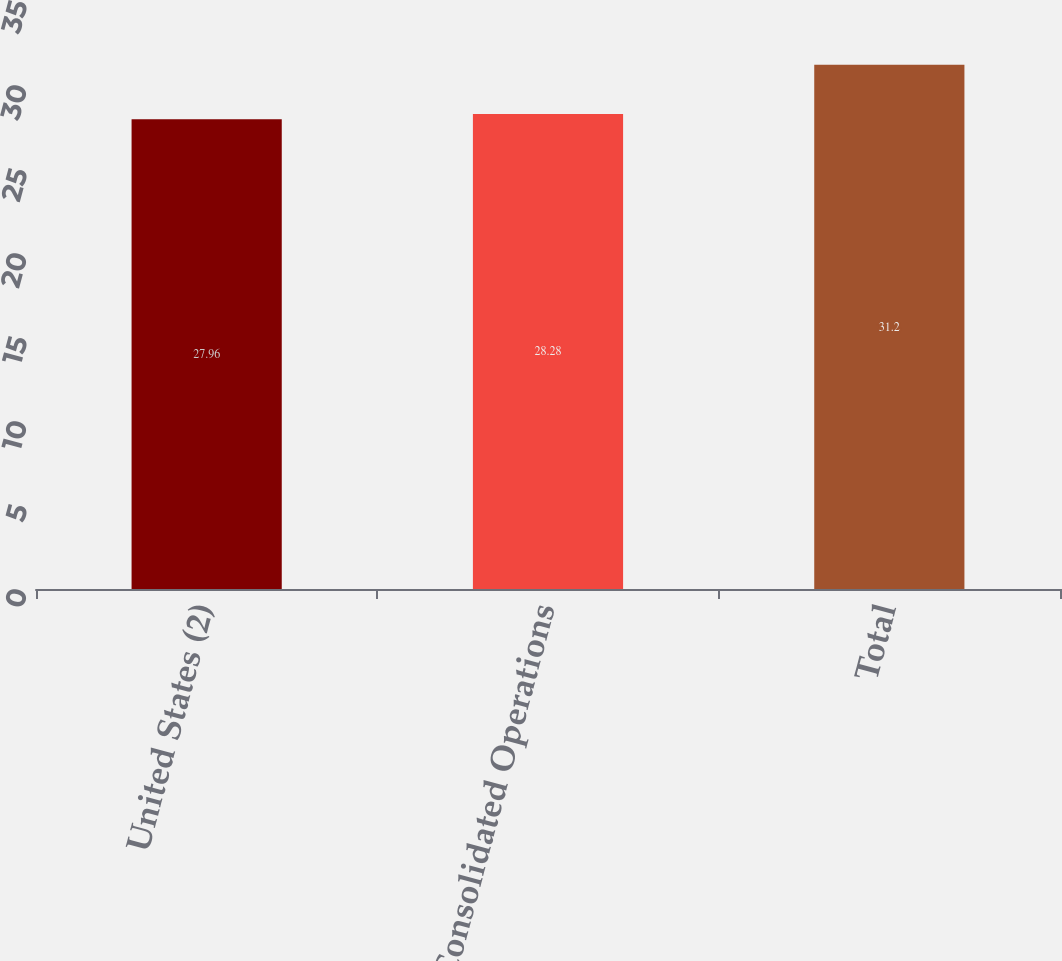Convert chart to OTSL. <chart><loc_0><loc_0><loc_500><loc_500><bar_chart><fcel>United States (2)<fcel>Total Consolidated Operations<fcel>Total<nl><fcel>27.96<fcel>28.28<fcel>31.2<nl></chart> 